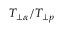Convert formula to latex. <formula><loc_0><loc_0><loc_500><loc_500>T _ { \perp \alpha } / T _ { \perp p }</formula> 